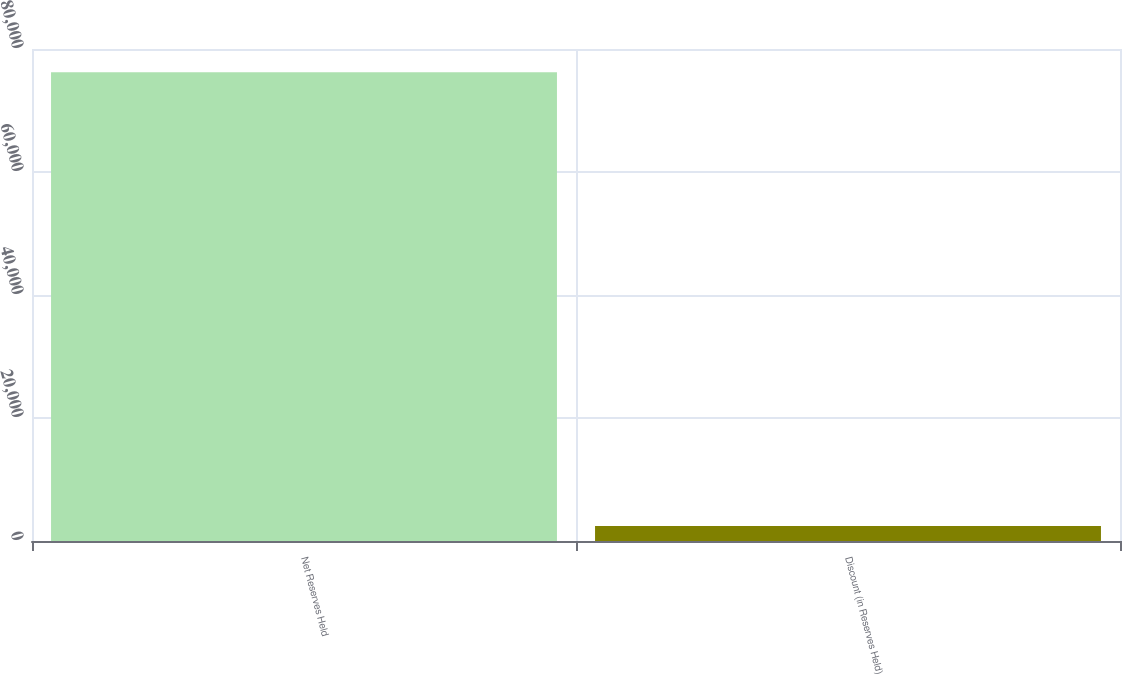Convert chart. <chart><loc_0><loc_0><loc_500><loc_500><bar_chart><fcel>Net Reserves Held<fcel>Discount (in Reserves Held)<nl><fcel>76216.8<fcel>2429<nl></chart> 